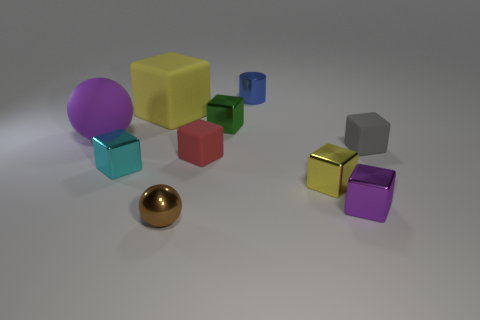The yellow object that is on the right side of the matte cube that is behind the small gray matte thing is what shape?
Ensure brevity in your answer.  Cube. What size is the sphere on the right side of the cyan object?
Your answer should be very brief. Small. Do the cyan block and the tiny gray cube have the same material?
Your answer should be compact. No. The large purple object that is the same material as the tiny red thing is what shape?
Your response must be concise. Sphere. Is there any other thing that is the same color as the big rubber block?
Your response must be concise. Yes. There is a large rubber thing that is to the right of the tiny cyan object; what color is it?
Provide a succinct answer. Yellow. There is a tiny cube that is on the left side of the big cube; is it the same color as the big matte ball?
Your answer should be compact. No. There is a green thing that is the same shape as the tiny red rubber thing; what is it made of?
Offer a very short reply. Metal. How many other purple rubber things have the same size as the purple rubber thing?
Make the answer very short. 0. The small cyan object has what shape?
Make the answer very short. Cube. 